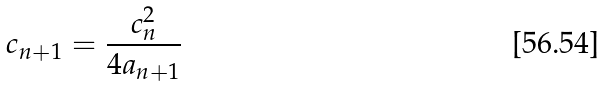Convert formula to latex. <formula><loc_0><loc_0><loc_500><loc_500>c _ { n + 1 } = { \frac { c _ { n } ^ { 2 } } { 4 a _ { n + 1 } } }</formula> 